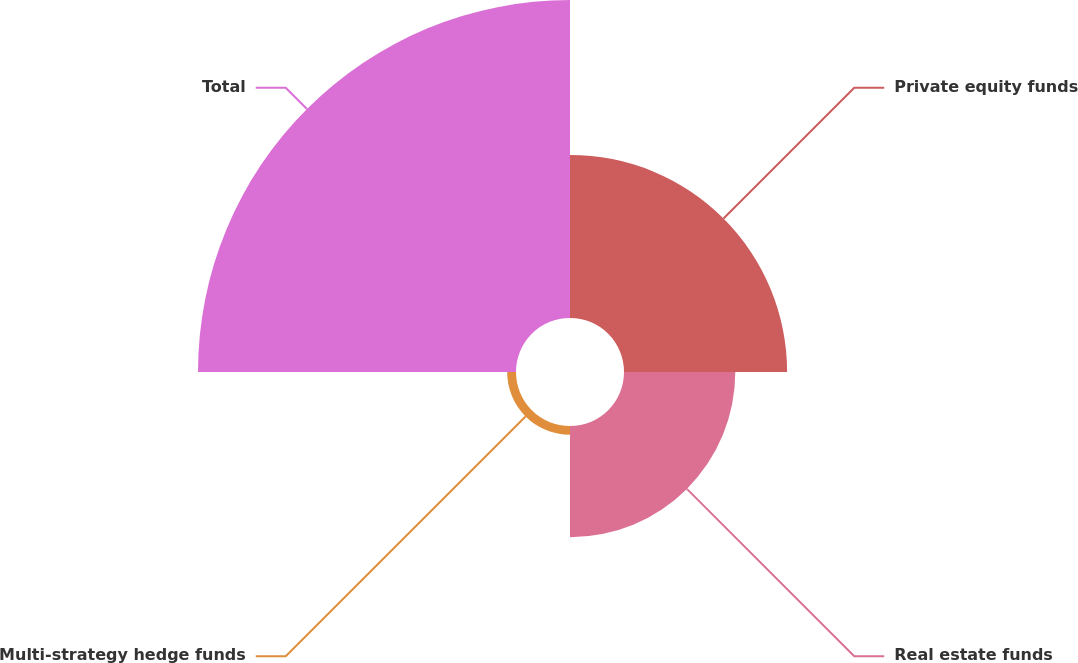Convert chart. <chart><loc_0><loc_0><loc_500><loc_500><pie_chart><fcel>Private equity funds<fcel>Real estate funds<fcel>Multi-strategy hedge funds<fcel>Total<nl><fcel>27.13%<fcel>18.51%<fcel>1.47%<fcel>52.89%<nl></chart> 